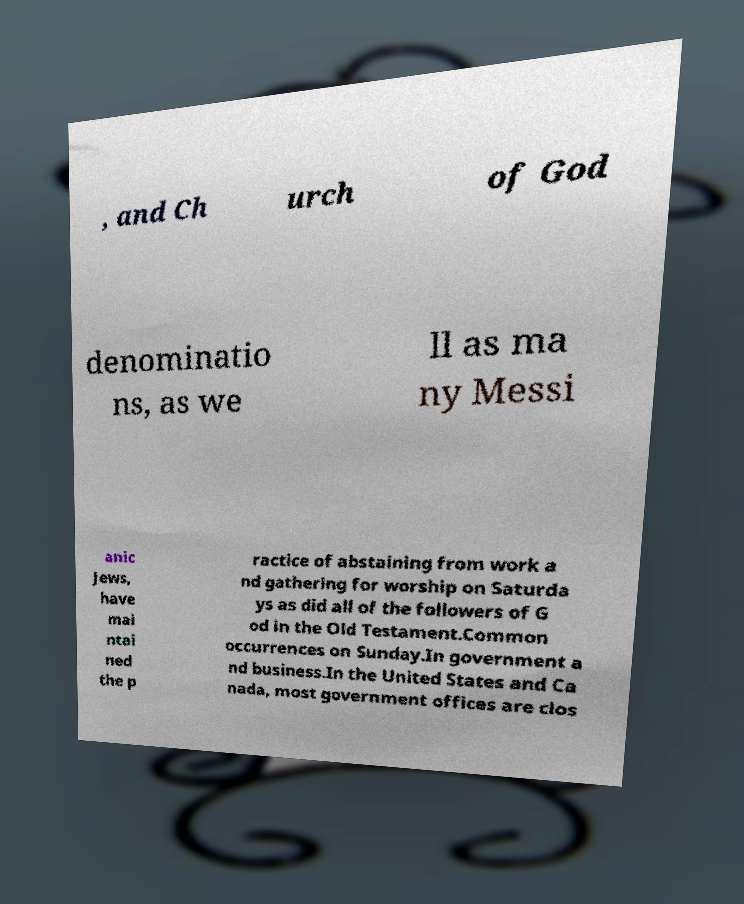Could you assist in decoding the text presented in this image and type it out clearly? , and Ch urch of God denominatio ns, as we ll as ma ny Messi anic Jews, have mai ntai ned the p ractice of abstaining from work a nd gathering for worship on Saturda ys as did all of the followers of G od in the Old Testament.Common occurrences on Sunday.In government a nd business.In the United States and Ca nada, most government offices are clos 